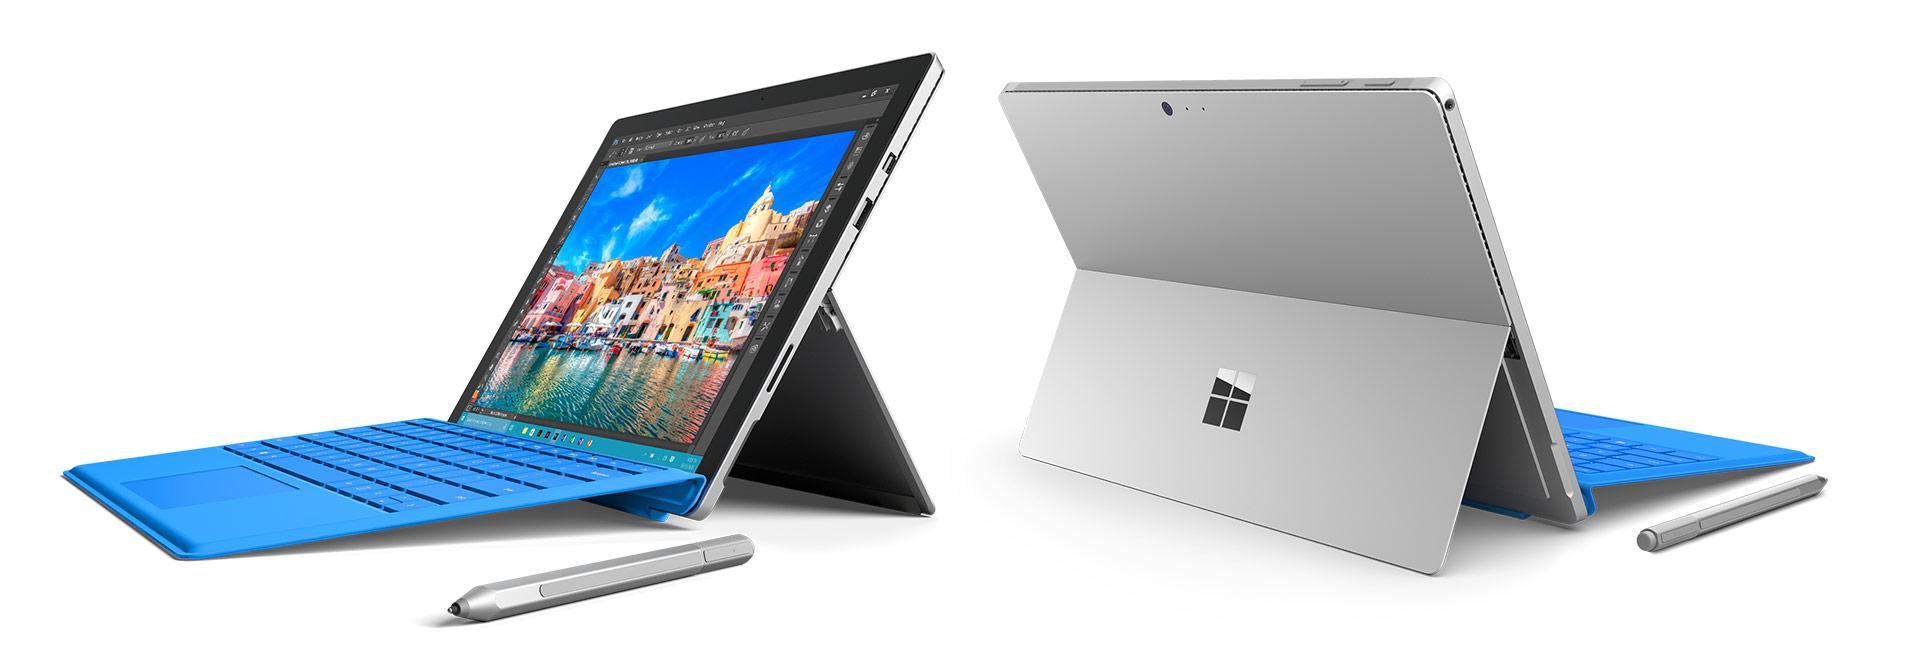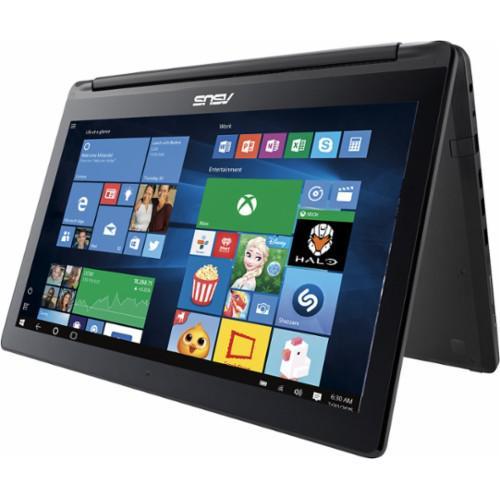The first image is the image on the left, the second image is the image on the right. Examine the images to the left and right. Is the description "There are more than two computers in total." accurate? Answer yes or no. Yes. The first image is the image on the left, the second image is the image on the right. For the images displayed, is the sentence "One image shows a laptop in two views, with its screen propped like an easel, and the other image includes a screen flipped to the back of a device." factually correct? Answer yes or no. Yes. 